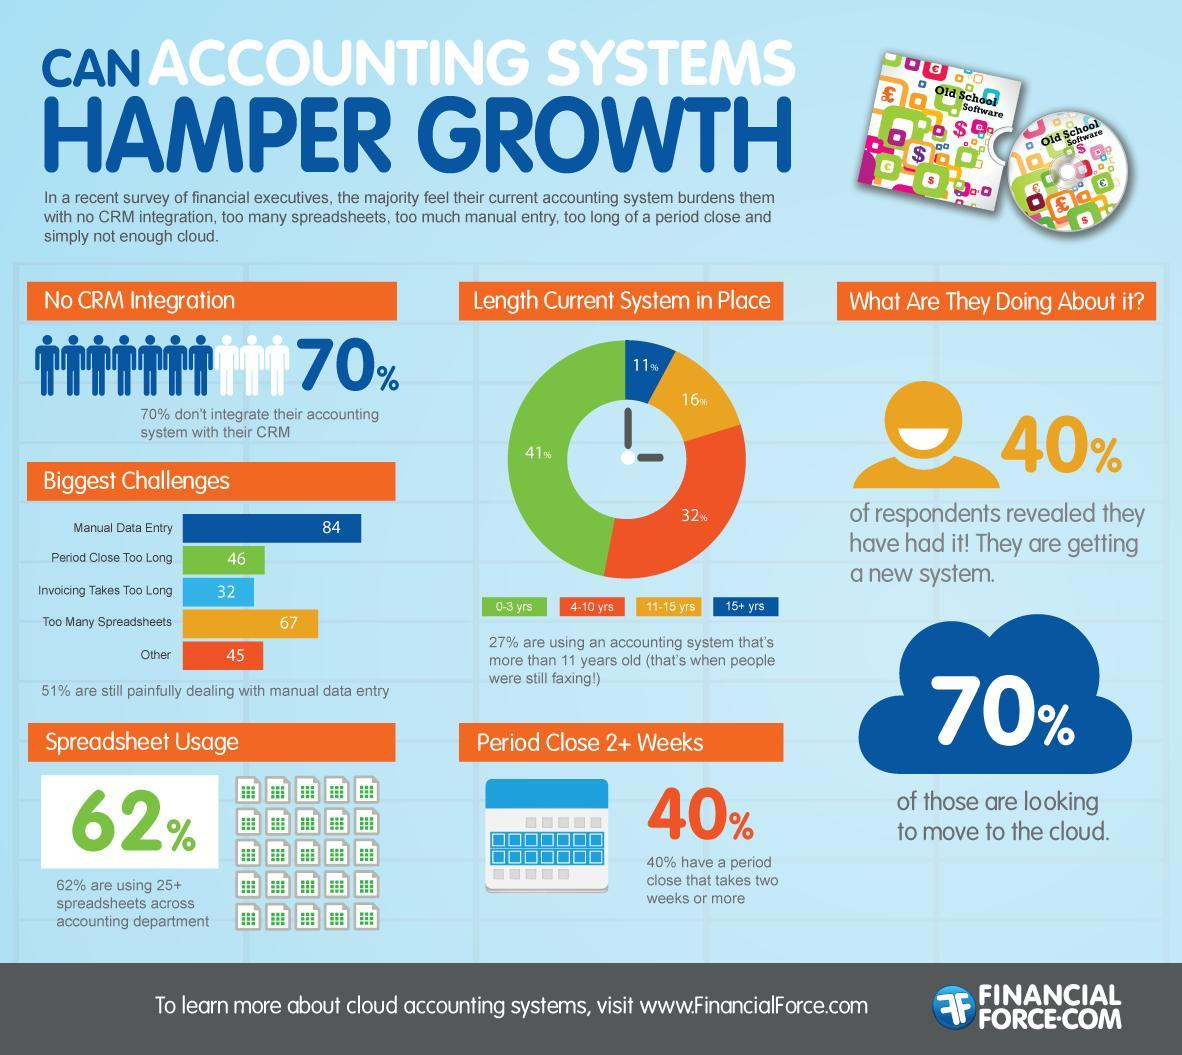What percent of people integrate their accounting system with their CRM?
Answer the question with a short phrase. 30% What percent are not moving to the cloud? 30% What percent of respondents are not getting a new system? 60% 11% of people use systems that are how old? 15+ yrs What percentage are using systems that are 4-10 yrs? 32% Which is the second biggest challenge? Too Many Spreadsheets 